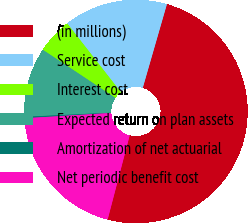Convert chart. <chart><loc_0><loc_0><loc_500><loc_500><pie_chart><fcel>(in millions)<fcel>Service cost<fcel>Interest cost<fcel>Expected return on plan assets<fcel>Amortization of net actuarial<fcel>Net periodic benefit cost<nl><fcel>49.61%<fcel>15.02%<fcel>5.14%<fcel>10.08%<fcel>0.2%<fcel>19.96%<nl></chart> 